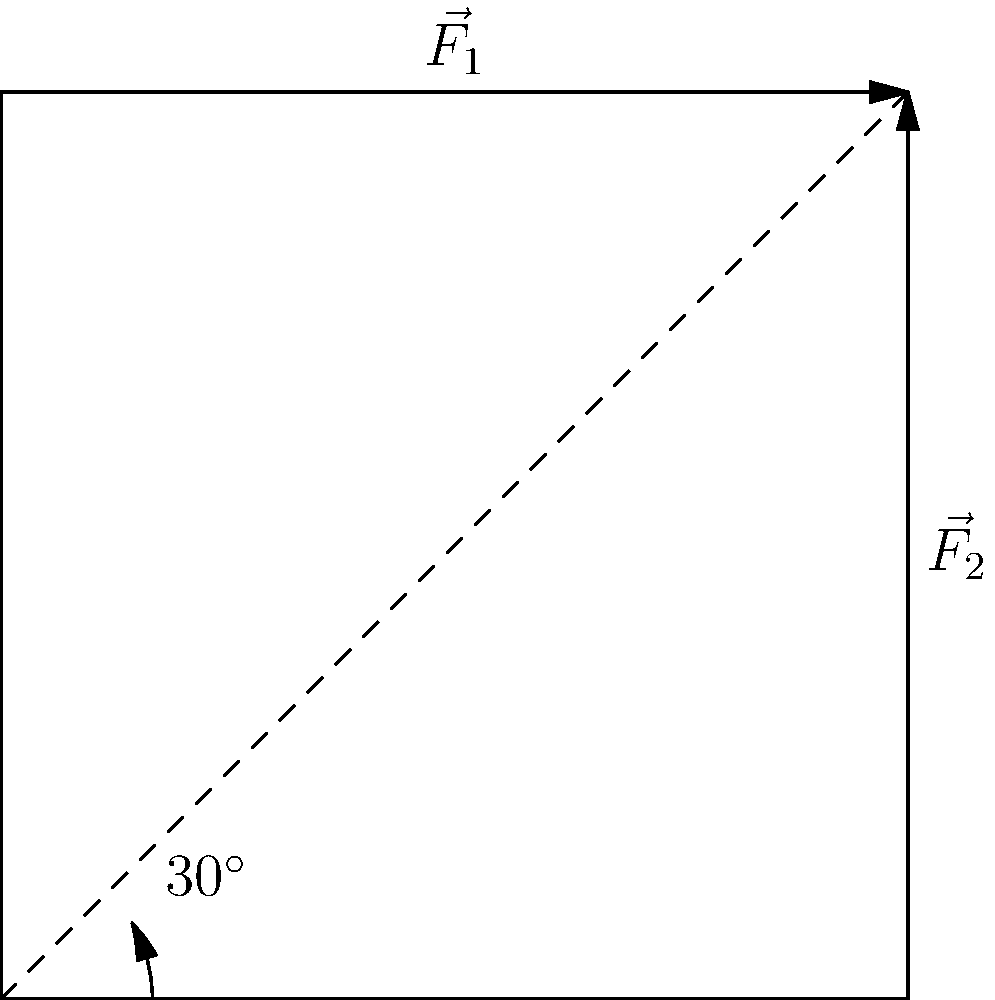In your latest mystery novel, a detective is analyzing a break-in attempt. Two force vectors, $\vec{F_1}$ and $\vec{F_2}$, were applied to a locked door. $\vec{F_1}$ has a magnitude of 500 N and is applied horizontally, while $\vec{F_2}$ has a magnitude of 400 N and is applied vertically upward. If the door hinges are located at a 30° angle from the horizontal, what is the magnitude of the resultant force vector along the door's axis of rotation? To solve this problem, we'll follow these steps:

1) First, we need to find the components of $\vec{F_1}$ and $\vec{F_2}$ along the door's axis of rotation (30° from horizontal).

2) For $\vec{F_1}$:
   The component along the 30° axis is $F_{1x} = 500 \cos(30°) = 500 \cdot \frac{\sqrt{3}}{2} = 250\sqrt{3}$ N

3) For $\vec{F_2}$:
   The component along the 30° axis is $F_{2x} = 400 \sin(30°) = 400 \cdot \frac{1}{2} = 200$ N

4) The total force along the door's axis of rotation is the sum of these components:
   $F_{total} = F_{1x} + F_{2x} = 250\sqrt{3} + 200$ N

5) To find the magnitude, we simplify:
   $F_{total} = 250\sqrt{3} + 200 \approx 633.01$ N

Therefore, the magnitude of the resultant force vector along the door's axis of rotation is approximately 633.01 N.
Answer: 633.01 N 